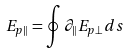<formula> <loc_0><loc_0><loc_500><loc_500>E _ { p \| } = \oint \partial _ { \| } E _ { p \bot } d s</formula> 